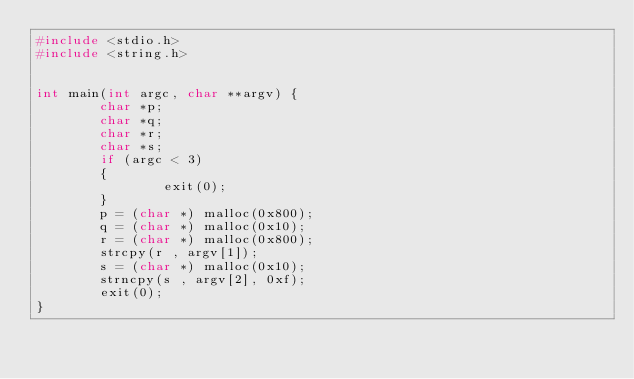Convert code to text. <code><loc_0><loc_0><loc_500><loc_500><_C_>#include <stdio.h>
#include <string.h>


int main(int argc, char **argv) {
        char *p;
        char *q;
        char *r;
        char *s;
        if (argc < 3)
        {
                exit(0);
        }
        p = (char *) malloc(0x800);
        q = (char *) malloc(0x10);
        r = (char *) malloc(0x800);
        strcpy(r , argv[1]);
        s = (char *) malloc(0x10);
        strncpy(s , argv[2], 0xf);
        exit(0);
}
</code> 